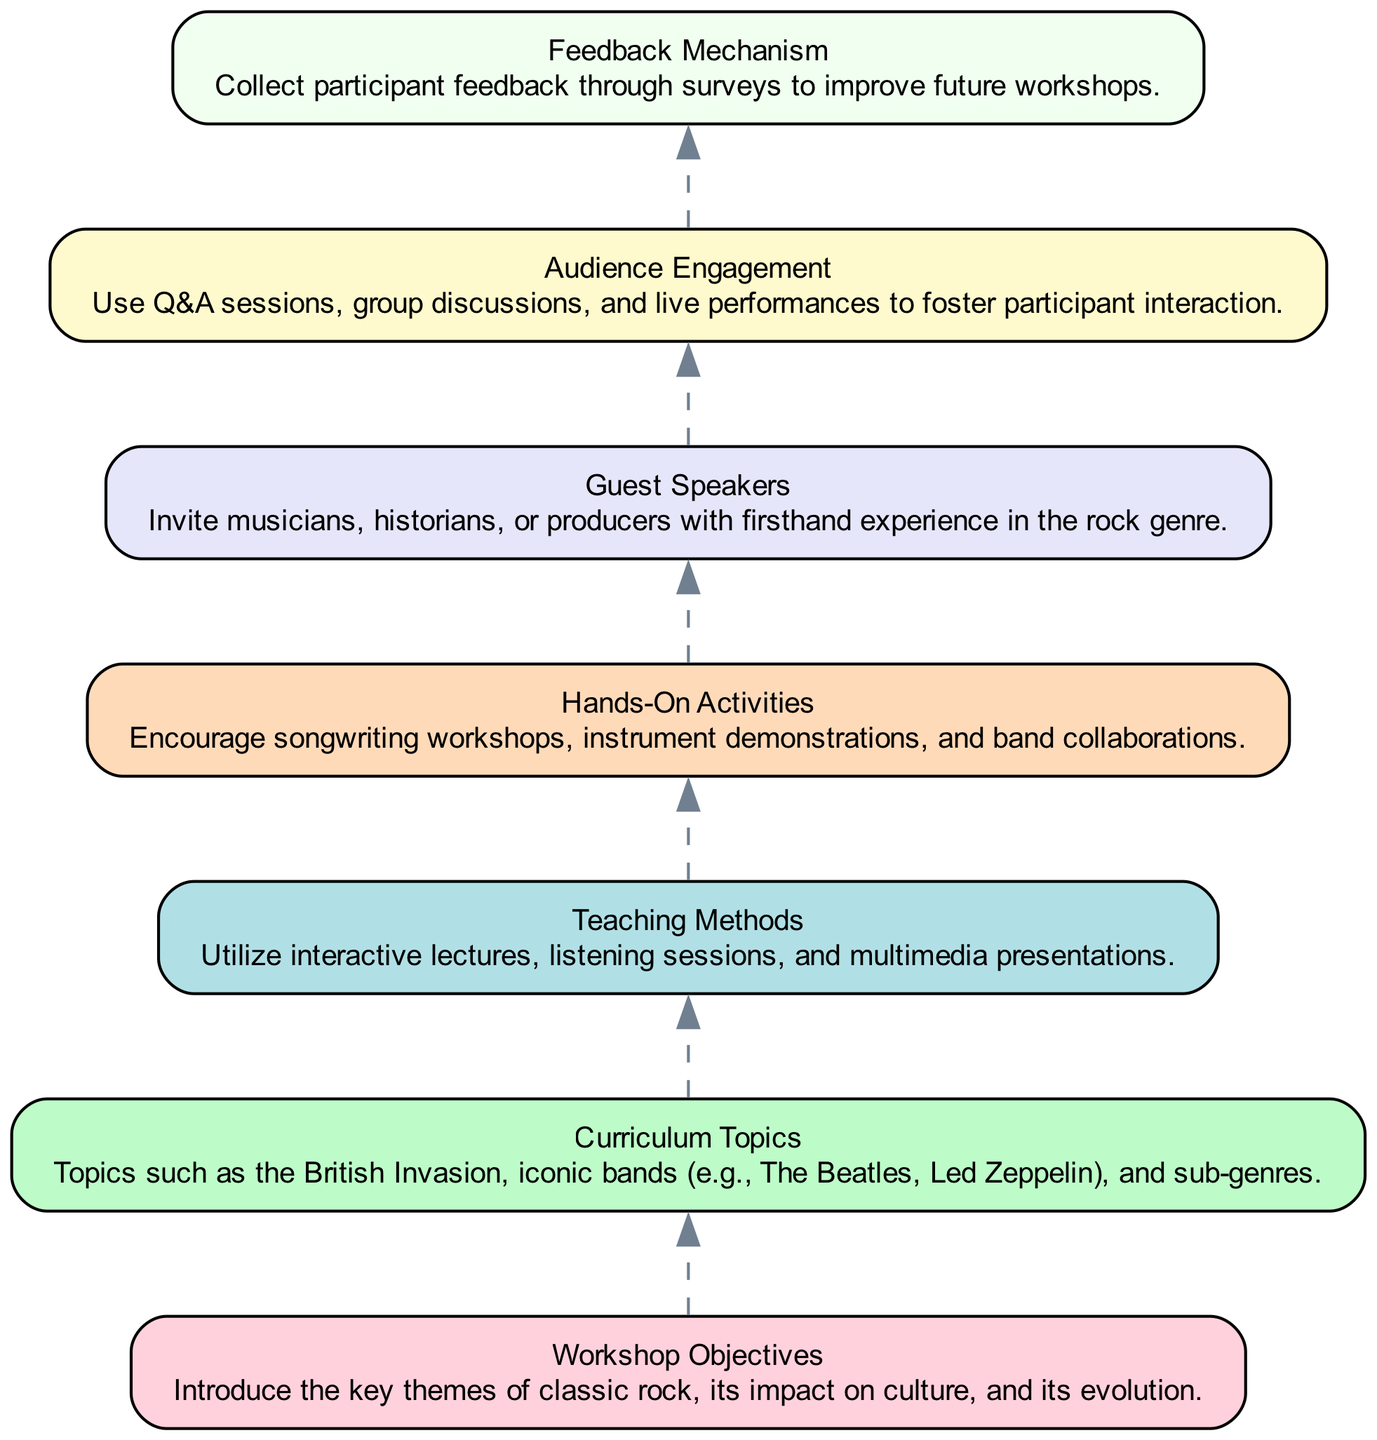What are the workshop objectives? The first node in the diagram specifies the workshop objectives, which are to introduce the key themes of classic rock, its impact on culture, and its evolution.
Answer: Introduce the key themes of classic rock, its impact on culture, and its evolution How many curriculum topics are mentioned? The second node addresses curriculum topics, and although it doesn't provide a specific number, it indicates that there are multiple topics such as the British Invasion and iconic bands. Thus, we can deduce at least 2 main topics are mentioned.
Answer: Multiple topics including the British Invasion and iconic bands What teaching method is used according to the diagram? The third node outlines the teaching methods employed in the workshops, highlighting interactive lectures, listening sessions, and multimedia presentations.
Answer: Interactive lectures, listening sessions, and multimedia presentations Which element comes after "Hands-On Activities"? According to the flow of the diagram, "Guest Speakers" immediately follows "Hands-On Activities," indicating that guest speakers are an important component of the workshops.
Answer: Guest Speakers What type of audience engagement is suggested? The sixth node details audience engagement methods, including Q&A sessions, group discussions, and live performances, which foster interaction between participants.
Answer: Q&A sessions, group discussions, and live performances How are feedback mechanisms incorporated? The seventh node specifies the feedback mechanism, stating that participant feedback will be collected through surveys. This indicates a systematic approach to gather insights and improve future workshops.
Answer: Collect participant feedback through surveys Why are guest speakers included in the workshop? The fifth node justifies the inclusion of guest speakers by indicating they will bring firsthand experience in the rock genre, enriching the overall educational experience for participants.
Answer: Firsthand experience in the rock genre Which element represents the final part of the flowchart? The last element in the flowchart is "Feedback Mechanism," which signifies it is the endpoint of the workshop structure as per the diagram's bottom-up flow.
Answer: Feedback Mechanism 